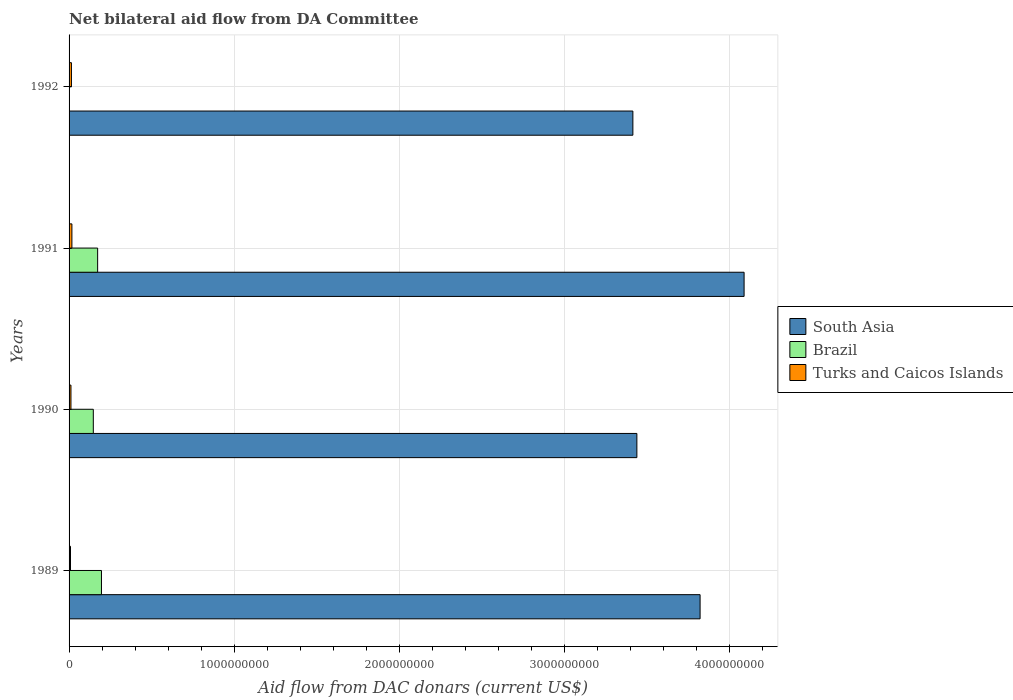Are the number of bars per tick equal to the number of legend labels?
Give a very brief answer. No. Are the number of bars on each tick of the Y-axis equal?
Make the answer very short. No. How many bars are there on the 1st tick from the bottom?
Offer a terse response. 3. What is the label of the 4th group of bars from the top?
Your answer should be compact. 1989. In how many cases, is the number of bars for a given year not equal to the number of legend labels?
Your answer should be very brief. 1. What is the aid flow in in Brazil in 1989?
Offer a terse response. 1.96e+08. Across all years, what is the maximum aid flow in in Turks and Caicos Islands?
Make the answer very short. 1.72e+07. Across all years, what is the minimum aid flow in in Turks and Caicos Islands?
Your response must be concise. 8.68e+06. What is the total aid flow in in South Asia in the graph?
Offer a terse response. 1.48e+1. What is the difference between the aid flow in in Turks and Caicos Islands in 1989 and that in 1992?
Offer a terse response. -5.70e+06. What is the difference between the aid flow in in Turks and Caicos Islands in 1992 and the aid flow in in Brazil in 1991?
Keep it short and to the point. -1.59e+08. What is the average aid flow in in Turks and Caicos Islands per year?
Provide a succinct answer. 1.29e+07. In the year 1990, what is the difference between the aid flow in in South Asia and aid flow in in Brazil?
Your response must be concise. 3.29e+09. What is the ratio of the aid flow in in South Asia in 1990 to that in 1992?
Make the answer very short. 1.01. Is the aid flow in in South Asia in 1989 less than that in 1992?
Provide a short and direct response. No. Is the difference between the aid flow in in South Asia in 1989 and 1990 greater than the difference between the aid flow in in Brazil in 1989 and 1990?
Keep it short and to the point. Yes. What is the difference between the highest and the second highest aid flow in in Turks and Caicos Islands?
Offer a terse response. 2.81e+06. What is the difference between the highest and the lowest aid flow in in Turks and Caicos Islands?
Provide a short and direct response. 8.51e+06. Is the sum of the aid flow in in Turks and Caicos Islands in 1989 and 1991 greater than the maximum aid flow in in South Asia across all years?
Your answer should be very brief. No. How many bars are there?
Ensure brevity in your answer.  11. How many years are there in the graph?
Your answer should be compact. 4. Does the graph contain grids?
Provide a succinct answer. Yes. Where does the legend appear in the graph?
Your answer should be compact. Center right. How many legend labels are there?
Give a very brief answer. 3. How are the legend labels stacked?
Your answer should be compact. Vertical. What is the title of the graph?
Your answer should be very brief. Net bilateral aid flow from DA Committee. What is the label or title of the X-axis?
Keep it short and to the point. Aid flow from DAC donars (current US$). What is the label or title of the Y-axis?
Keep it short and to the point. Years. What is the Aid flow from DAC donars (current US$) of South Asia in 1989?
Provide a succinct answer. 3.82e+09. What is the Aid flow from DAC donars (current US$) in Brazil in 1989?
Provide a short and direct response. 1.96e+08. What is the Aid flow from DAC donars (current US$) of Turks and Caicos Islands in 1989?
Keep it short and to the point. 8.68e+06. What is the Aid flow from DAC donars (current US$) of South Asia in 1990?
Your response must be concise. 3.44e+09. What is the Aid flow from DAC donars (current US$) of Brazil in 1990?
Provide a succinct answer. 1.47e+08. What is the Aid flow from DAC donars (current US$) of Turks and Caicos Islands in 1990?
Provide a succinct answer. 1.14e+07. What is the Aid flow from DAC donars (current US$) in South Asia in 1991?
Provide a short and direct response. 4.09e+09. What is the Aid flow from DAC donars (current US$) in Brazil in 1991?
Make the answer very short. 1.73e+08. What is the Aid flow from DAC donars (current US$) of Turks and Caicos Islands in 1991?
Give a very brief answer. 1.72e+07. What is the Aid flow from DAC donars (current US$) of South Asia in 1992?
Your response must be concise. 3.42e+09. What is the Aid flow from DAC donars (current US$) in Turks and Caicos Islands in 1992?
Provide a succinct answer. 1.44e+07. Across all years, what is the maximum Aid flow from DAC donars (current US$) in South Asia?
Your answer should be compact. 4.09e+09. Across all years, what is the maximum Aid flow from DAC donars (current US$) in Brazil?
Ensure brevity in your answer.  1.96e+08. Across all years, what is the maximum Aid flow from DAC donars (current US$) in Turks and Caicos Islands?
Provide a succinct answer. 1.72e+07. Across all years, what is the minimum Aid flow from DAC donars (current US$) in South Asia?
Give a very brief answer. 3.42e+09. Across all years, what is the minimum Aid flow from DAC donars (current US$) of Turks and Caicos Islands?
Keep it short and to the point. 8.68e+06. What is the total Aid flow from DAC donars (current US$) of South Asia in the graph?
Provide a succinct answer. 1.48e+1. What is the total Aid flow from DAC donars (current US$) in Brazil in the graph?
Provide a succinct answer. 5.16e+08. What is the total Aid flow from DAC donars (current US$) of Turks and Caicos Islands in the graph?
Provide a short and direct response. 5.17e+07. What is the difference between the Aid flow from DAC donars (current US$) in South Asia in 1989 and that in 1990?
Your answer should be compact. 3.83e+08. What is the difference between the Aid flow from DAC donars (current US$) of Brazil in 1989 and that in 1990?
Your answer should be very brief. 4.95e+07. What is the difference between the Aid flow from DAC donars (current US$) of Turks and Caicos Islands in 1989 and that in 1990?
Your response must be concise. -2.77e+06. What is the difference between the Aid flow from DAC donars (current US$) in South Asia in 1989 and that in 1991?
Provide a succinct answer. -2.67e+08. What is the difference between the Aid flow from DAC donars (current US$) of Brazil in 1989 and that in 1991?
Offer a terse response. 2.33e+07. What is the difference between the Aid flow from DAC donars (current US$) of Turks and Caicos Islands in 1989 and that in 1991?
Ensure brevity in your answer.  -8.51e+06. What is the difference between the Aid flow from DAC donars (current US$) in South Asia in 1989 and that in 1992?
Offer a very short reply. 4.07e+08. What is the difference between the Aid flow from DAC donars (current US$) of Turks and Caicos Islands in 1989 and that in 1992?
Your answer should be compact. -5.70e+06. What is the difference between the Aid flow from DAC donars (current US$) of South Asia in 1990 and that in 1991?
Ensure brevity in your answer.  -6.50e+08. What is the difference between the Aid flow from DAC donars (current US$) of Brazil in 1990 and that in 1991?
Ensure brevity in your answer.  -2.62e+07. What is the difference between the Aid flow from DAC donars (current US$) in Turks and Caicos Islands in 1990 and that in 1991?
Offer a very short reply. -5.74e+06. What is the difference between the Aid flow from DAC donars (current US$) in South Asia in 1990 and that in 1992?
Give a very brief answer. 2.42e+07. What is the difference between the Aid flow from DAC donars (current US$) in Turks and Caicos Islands in 1990 and that in 1992?
Keep it short and to the point. -2.93e+06. What is the difference between the Aid flow from DAC donars (current US$) in South Asia in 1991 and that in 1992?
Your answer should be compact. 6.74e+08. What is the difference between the Aid flow from DAC donars (current US$) of Turks and Caicos Islands in 1991 and that in 1992?
Your answer should be very brief. 2.81e+06. What is the difference between the Aid flow from DAC donars (current US$) of South Asia in 1989 and the Aid flow from DAC donars (current US$) of Brazil in 1990?
Give a very brief answer. 3.68e+09. What is the difference between the Aid flow from DAC donars (current US$) in South Asia in 1989 and the Aid flow from DAC donars (current US$) in Turks and Caicos Islands in 1990?
Your answer should be very brief. 3.81e+09. What is the difference between the Aid flow from DAC donars (current US$) of Brazil in 1989 and the Aid flow from DAC donars (current US$) of Turks and Caicos Islands in 1990?
Provide a short and direct response. 1.85e+08. What is the difference between the Aid flow from DAC donars (current US$) in South Asia in 1989 and the Aid flow from DAC donars (current US$) in Brazil in 1991?
Keep it short and to the point. 3.65e+09. What is the difference between the Aid flow from DAC donars (current US$) of South Asia in 1989 and the Aid flow from DAC donars (current US$) of Turks and Caicos Islands in 1991?
Your answer should be compact. 3.81e+09. What is the difference between the Aid flow from DAC donars (current US$) of Brazil in 1989 and the Aid flow from DAC donars (current US$) of Turks and Caicos Islands in 1991?
Provide a succinct answer. 1.79e+08. What is the difference between the Aid flow from DAC donars (current US$) in South Asia in 1989 and the Aid flow from DAC donars (current US$) in Turks and Caicos Islands in 1992?
Your response must be concise. 3.81e+09. What is the difference between the Aid flow from DAC donars (current US$) of Brazil in 1989 and the Aid flow from DAC donars (current US$) of Turks and Caicos Islands in 1992?
Offer a terse response. 1.82e+08. What is the difference between the Aid flow from DAC donars (current US$) in South Asia in 1990 and the Aid flow from DAC donars (current US$) in Brazil in 1991?
Give a very brief answer. 3.27e+09. What is the difference between the Aid flow from DAC donars (current US$) in South Asia in 1990 and the Aid flow from DAC donars (current US$) in Turks and Caicos Islands in 1991?
Provide a succinct answer. 3.42e+09. What is the difference between the Aid flow from DAC donars (current US$) in Brazil in 1990 and the Aid flow from DAC donars (current US$) in Turks and Caicos Islands in 1991?
Your response must be concise. 1.30e+08. What is the difference between the Aid flow from DAC donars (current US$) in South Asia in 1990 and the Aid flow from DAC donars (current US$) in Turks and Caicos Islands in 1992?
Offer a very short reply. 3.43e+09. What is the difference between the Aid flow from DAC donars (current US$) of Brazil in 1990 and the Aid flow from DAC donars (current US$) of Turks and Caicos Islands in 1992?
Your answer should be compact. 1.32e+08. What is the difference between the Aid flow from DAC donars (current US$) in South Asia in 1991 and the Aid flow from DAC donars (current US$) in Turks and Caicos Islands in 1992?
Provide a succinct answer. 4.08e+09. What is the difference between the Aid flow from DAC donars (current US$) of Brazil in 1991 and the Aid flow from DAC donars (current US$) of Turks and Caicos Islands in 1992?
Provide a succinct answer. 1.59e+08. What is the average Aid flow from DAC donars (current US$) of South Asia per year?
Ensure brevity in your answer.  3.69e+09. What is the average Aid flow from DAC donars (current US$) in Brazil per year?
Offer a very short reply. 1.29e+08. What is the average Aid flow from DAC donars (current US$) of Turks and Caicos Islands per year?
Keep it short and to the point. 1.29e+07. In the year 1989, what is the difference between the Aid flow from DAC donars (current US$) of South Asia and Aid flow from DAC donars (current US$) of Brazil?
Your answer should be compact. 3.63e+09. In the year 1989, what is the difference between the Aid flow from DAC donars (current US$) of South Asia and Aid flow from DAC donars (current US$) of Turks and Caicos Islands?
Your answer should be compact. 3.81e+09. In the year 1989, what is the difference between the Aid flow from DAC donars (current US$) of Brazil and Aid flow from DAC donars (current US$) of Turks and Caicos Islands?
Give a very brief answer. 1.88e+08. In the year 1990, what is the difference between the Aid flow from DAC donars (current US$) of South Asia and Aid flow from DAC donars (current US$) of Brazil?
Your answer should be compact. 3.29e+09. In the year 1990, what is the difference between the Aid flow from DAC donars (current US$) of South Asia and Aid flow from DAC donars (current US$) of Turks and Caicos Islands?
Your answer should be compact. 3.43e+09. In the year 1990, what is the difference between the Aid flow from DAC donars (current US$) in Brazil and Aid flow from DAC donars (current US$) in Turks and Caicos Islands?
Ensure brevity in your answer.  1.35e+08. In the year 1991, what is the difference between the Aid flow from DAC donars (current US$) of South Asia and Aid flow from DAC donars (current US$) of Brazil?
Give a very brief answer. 3.92e+09. In the year 1991, what is the difference between the Aid flow from DAC donars (current US$) in South Asia and Aid flow from DAC donars (current US$) in Turks and Caicos Islands?
Your answer should be very brief. 4.07e+09. In the year 1991, what is the difference between the Aid flow from DAC donars (current US$) in Brazil and Aid flow from DAC donars (current US$) in Turks and Caicos Islands?
Your answer should be compact. 1.56e+08. In the year 1992, what is the difference between the Aid flow from DAC donars (current US$) in South Asia and Aid flow from DAC donars (current US$) in Turks and Caicos Islands?
Ensure brevity in your answer.  3.40e+09. What is the ratio of the Aid flow from DAC donars (current US$) of South Asia in 1989 to that in 1990?
Your answer should be very brief. 1.11. What is the ratio of the Aid flow from DAC donars (current US$) in Brazil in 1989 to that in 1990?
Provide a short and direct response. 1.34. What is the ratio of the Aid flow from DAC donars (current US$) in Turks and Caicos Islands in 1989 to that in 1990?
Your answer should be very brief. 0.76. What is the ratio of the Aid flow from DAC donars (current US$) of South Asia in 1989 to that in 1991?
Ensure brevity in your answer.  0.93. What is the ratio of the Aid flow from DAC donars (current US$) in Brazil in 1989 to that in 1991?
Your response must be concise. 1.13. What is the ratio of the Aid flow from DAC donars (current US$) of Turks and Caicos Islands in 1989 to that in 1991?
Offer a terse response. 0.5. What is the ratio of the Aid flow from DAC donars (current US$) of South Asia in 1989 to that in 1992?
Your answer should be compact. 1.12. What is the ratio of the Aid flow from DAC donars (current US$) of Turks and Caicos Islands in 1989 to that in 1992?
Your response must be concise. 0.6. What is the ratio of the Aid flow from DAC donars (current US$) in South Asia in 1990 to that in 1991?
Keep it short and to the point. 0.84. What is the ratio of the Aid flow from DAC donars (current US$) of Brazil in 1990 to that in 1991?
Provide a short and direct response. 0.85. What is the ratio of the Aid flow from DAC donars (current US$) in Turks and Caicos Islands in 1990 to that in 1991?
Your answer should be very brief. 0.67. What is the ratio of the Aid flow from DAC donars (current US$) of South Asia in 1990 to that in 1992?
Provide a succinct answer. 1.01. What is the ratio of the Aid flow from DAC donars (current US$) in Turks and Caicos Islands in 1990 to that in 1992?
Offer a very short reply. 0.8. What is the ratio of the Aid flow from DAC donars (current US$) in South Asia in 1991 to that in 1992?
Your response must be concise. 1.2. What is the ratio of the Aid flow from DAC donars (current US$) of Turks and Caicos Islands in 1991 to that in 1992?
Keep it short and to the point. 1.2. What is the difference between the highest and the second highest Aid flow from DAC donars (current US$) of South Asia?
Keep it short and to the point. 2.67e+08. What is the difference between the highest and the second highest Aid flow from DAC donars (current US$) of Brazil?
Offer a terse response. 2.33e+07. What is the difference between the highest and the second highest Aid flow from DAC donars (current US$) in Turks and Caicos Islands?
Your answer should be very brief. 2.81e+06. What is the difference between the highest and the lowest Aid flow from DAC donars (current US$) in South Asia?
Your answer should be compact. 6.74e+08. What is the difference between the highest and the lowest Aid flow from DAC donars (current US$) of Brazil?
Give a very brief answer. 1.96e+08. What is the difference between the highest and the lowest Aid flow from DAC donars (current US$) of Turks and Caicos Islands?
Provide a succinct answer. 8.51e+06. 